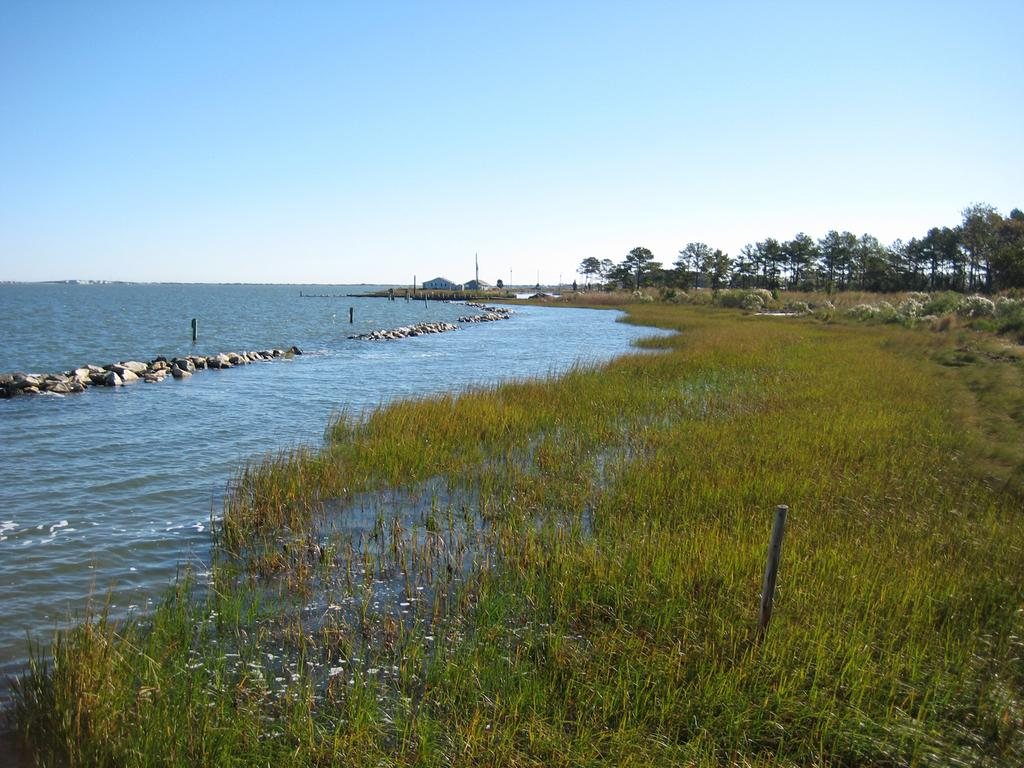What is visible in the foreground of the image? In the foreground of the image, there is grass, water, stones, and poles. What type of vegetation can be seen in the background of the image? There are trees in the background of the image. What part of the natural environment is visible in the background of the image? The sky is visible in the background of the image. How many dimes are scattered on the grass in the image? There are no dimes present in the image; it features grass, water, stones, and poles in the foreground. What type of rock is visible in the image? There is no specific rock mentioned in the image; it only mentions stones in the foreground. 